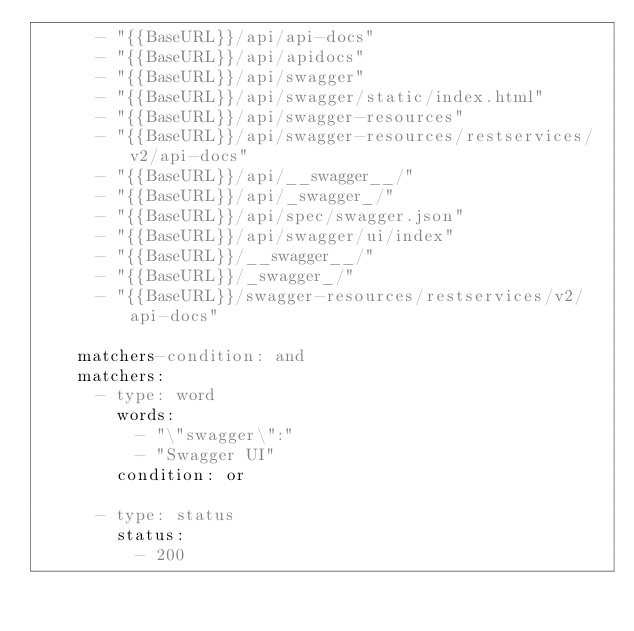<code> <loc_0><loc_0><loc_500><loc_500><_YAML_>      - "{{BaseURL}}/api/api-docs"
      - "{{BaseURL}}/api/apidocs"
      - "{{BaseURL}}/api/swagger"
      - "{{BaseURL}}/api/swagger/static/index.html"
      - "{{BaseURL}}/api/swagger-resources"
      - "{{BaseURL}}/api/swagger-resources/restservices/v2/api-docs"
      - "{{BaseURL}}/api/__swagger__/"
      - "{{BaseURL}}/api/_swagger_/"
      - "{{BaseURL}}/api/spec/swagger.json"
      - "{{BaseURL}}/api/swagger/ui/index"
      - "{{BaseURL}}/__swagger__/"
      - "{{BaseURL}}/_swagger_/"
      - "{{BaseURL}}/swagger-resources/restservices/v2/api-docs"

    matchers-condition: and
    matchers:
      - type: word
        words:
          - "\"swagger\":"
          - "Swagger UI"
        condition: or

      - type: status
        status:
          - 200
</code> 